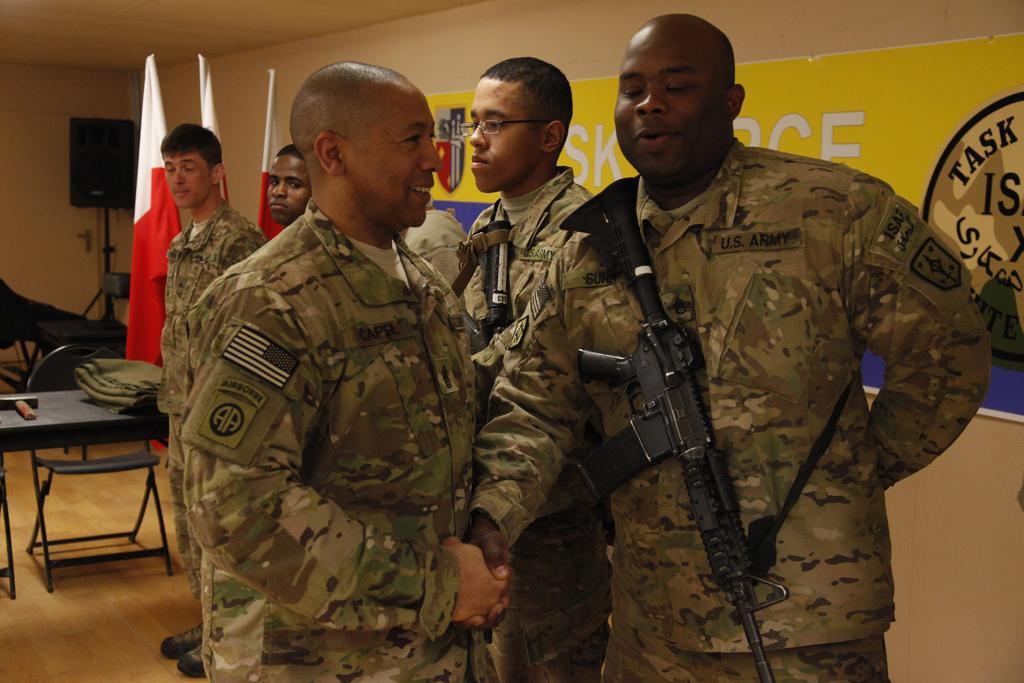Please provide a concise description of this image. In this image I can see few persons wearing uniforms are standing. I can see two of them are wearing guns which are black in color. In the background I can see the black colored table with few objects on it, a chair, the wall, the ceiling, few flags and a huge banner attached to the wall. 